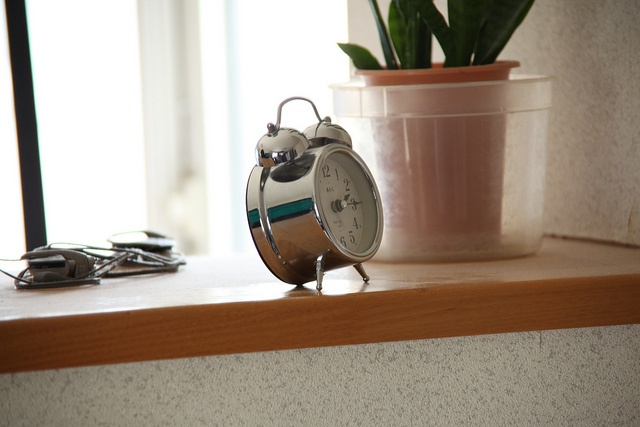Describe the objects in this image and their specific colors. I can see potted plant in white, brown, black, and gray tones and clock in white, gray, black, maroon, and darkgray tones in this image. 